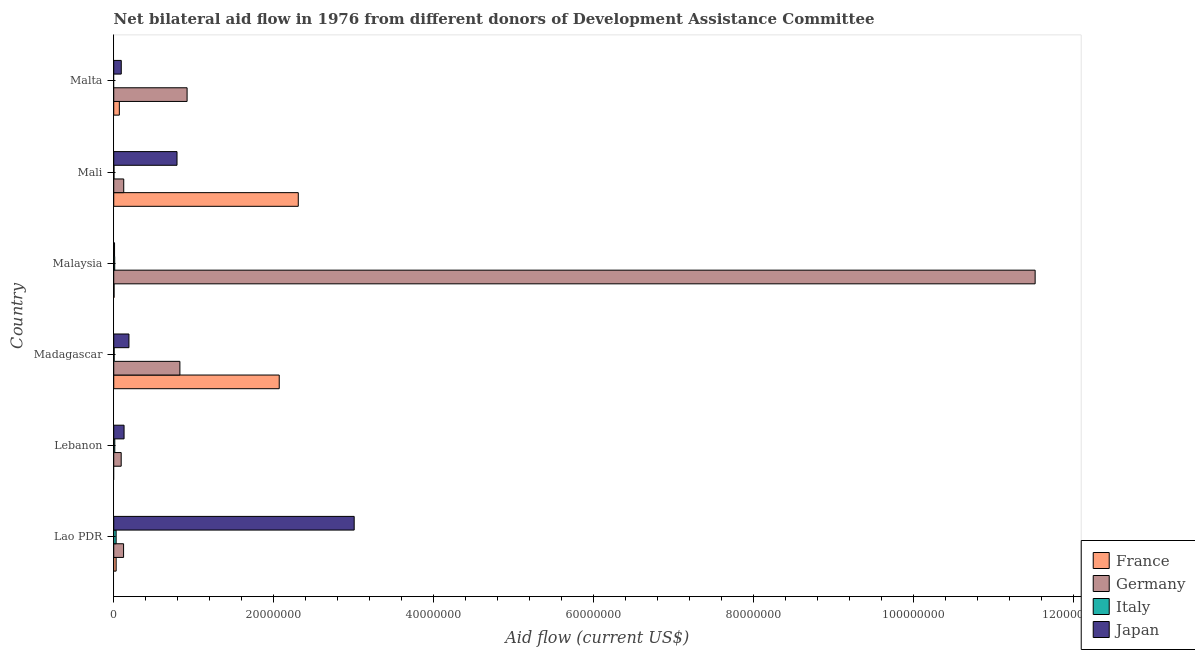How many groups of bars are there?
Your answer should be compact. 6. What is the label of the 4th group of bars from the top?
Provide a succinct answer. Madagascar. In how many cases, is the number of bars for a given country not equal to the number of legend labels?
Make the answer very short. 2. What is the amount of aid given by france in Lao PDR?
Make the answer very short. 3.00e+05. Across all countries, what is the maximum amount of aid given by italy?
Keep it short and to the point. 3.00e+05. In which country was the amount of aid given by japan maximum?
Make the answer very short. Lao PDR. What is the total amount of aid given by france in the graph?
Ensure brevity in your answer.  4.48e+07. What is the difference between the amount of aid given by germany in Lebanon and that in Mali?
Offer a terse response. -3.20e+05. What is the difference between the amount of aid given by italy in Malaysia and the amount of aid given by germany in Lao PDR?
Your answer should be very brief. -1.11e+06. What is the average amount of aid given by japan per country?
Offer a terse response. 7.03e+06. What is the difference between the amount of aid given by italy and amount of aid given by japan in Lebanon?
Ensure brevity in your answer.  -1.16e+06. In how many countries, is the amount of aid given by germany greater than 84000000 US$?
Ensure brevity in your answer.  1. Is the amount of aid given by france in Lao PDR less than that in Mali?
Keep it short and to the point. Yes. What is the difference between the highest and the second highest amount of aid given by france?
Ensure brevity in your answer.  2.38e+06. What is the difference between the highest and the lowest amount of aid given by italy?
Your response must be concise. 3.00e+05. Is the sum of the amount of aid given by japan in Lao PDR and Malaysia greater than the maximum amount of aid given by france across all countries?
Your response must be concise. Yes. Is it the case that in every country, the sum of the amount of aid given by france and amount of aid given by germany is greater than the amount of aid given by italy?
Ensure brevity in your answer.  Yes. What is the difference between two consecutive major ticks on the X-axis?
Provide a succinct answer. 2.00e+07. Does the graph contain any zero values?
Give a very brief answer. Yes. How many legend labels are there?
Offer a terse response. 4. What is the title of the graph?
Your response must be concise. Net bilateral aid flow in 1976 from different donors of Development Assistance Committee. What is the label or title of the Y-axis?
Your response must be concise. Country. What is the Aid flow (current US$) in Germany in Lao PDR?
Your answer should be compact. 1.23e+06. What is the Aid flow (current US$) of Italy in Lao PDR?
Your answer should be compact. 3.00e+05. What is the Aid flow (current US$) in Japan in Lao PDR?
Your response must be concise. 3.01e+07. What is the Aid flow (current US$) of Germany in Lebanon?
Your answer should be compact. 9.30e+05. What is the Aid flow (current US$) in Japan in Lebanon?
Your answer should be compact. 1.29e+06. What is the Aid flow (current US$) of France in Madagascar?
Your response must be concise. 2.07e+07. What is the Aid flow (current US$) of Germany in Madagascar?
Give a very brief answer. 8.27e+06. What is the Aid flow (current US$) in Japan in Madagascar?
Your answer should be very brief. 1.90e+06. What is the Aid flow (current US$) in France in Malaysia?
Ensure brevity in your answer.  4.00e+04. What is the Aid flow (current US$) of Germany in Malaysia?
Offer a very short reply. 1.15e+08. What is the Aid flow (current US$) of Italy in Malaysia?
Your answer should be compact. 1.20e+05. What is the Aid flow (current US$) of France in Mali?
Provide a succinct answer. 2.31e+07. What is the Aid flow (current US$) in Germany in Mali?
Give a very brief answer. 1.25e+06. What is the Aid flow (current US$) in Italy in Mali?
Ensure brevity in your answer.  3.00e+04. What is the Aid flow (current US$) of Japan in Mali?
Keep it short and to the point. 7.91e+06. What is the Aid flow (current US$) in France in Malta?
Give a very brief answer. 7.00e+05. What is the Aid flow (current US$) of Germany in Malta?
Your answer should be very brief. 9.17e+06. What is the Aid flow (current US$) of Japan in Malta?
Make the answer very short. 9.40e+05. Across all countries, what is the maximum Aid flow (current US$) of France?
Provide a short and direct response. 2.31e+07. Across all countries, what is the maximum Aid flow (current US$) of Germany?
Ensure brevity in your answer.  1.15e+08. Across all countries, what is the maximum Aid flow (current US$) in Italy?
Your answer should be very brief. 3.00e+05. Across all countries, what is the maximum Aid flow (current US$) of Japan?
Your answer should be compact. 3.01e+07. Across all countries, what is the minimum Aid flow (current US$) of Germany?
Give a very brief answer. 9.30e+05. Across all countries, what is the minimum Aid flow (current US$) in Italy?
Ensure brevity in your answer.  0. Across all countries, what is the minimum Aid flow (current US$) in Japan?
Your answer should be compact. 1.00e+05. What is the total Aid flow (current US$) of France in the graph?
Give a very brief answer. 4.48e+07. What is the total Aid flow (current US$) of Germany in the graph?
Offer a terse response. 1.36e+08. What is the total Aid flow (current US$) of Italy in the graph?
Ensure brevity in your answer.  6.30e+05. What is the total Aid flow (current US$) in Japan in the graph?
Your answer should be compact. 4.22e+07. What is the difference between the Aid flow (current US$) in Italy in Lao PDR and that in Lebanon?
Provide a succinct answer. 1.70e+05. What is the difference between the Aid flow (current US$) in Japan in Lao PDR and that in Lebanon?
Provide a short and direct response. 2.88e+07. What is the difference between the Aid flow (current US$) in France in Lao PDR and that in Madagascar?
Give a very brief answer. -2.04e+07. What is the difference between the Aid flow (current US$) of Germany in Lao PDR and that in Madagascar?
Provide a short and direct response. -7.04e+06. What is the difference between the Aid flow (current US$) of Japan in Lao PDR and that in Madagascar?
Provide a short and direct response. 2.82e+07. What is the difference between the Aid flow (current US$) of Germany in Lao PDR and that in Malaysia?
Ensure brevity in your answer.  -1.14e+08. What is the difference between the Aid flow (current US$) of Japan in Lao PDR and that in Malaysia?
Your response must be concise. 3.00e+07. What is the difference between the Aid flow (current US$) in France in Lao PDR and that in Mali?
Provide a short and direct response. -2.28e+07. What is the difference between the Aid flow (current US$) in Japan in Lao PDR and that in Mali?
Provide a short and direct response. 2.22e+07. What is the difference between the Aid flow (current US$) of France in Lao PDR and that in Malta?
Your answer should be very brief. -4.00e+05. What is the difference between the Aid flow (current US$) in Germany in Lao PDR and that in Malta?
Keep it short and to the point. -7.94e+06. What is the difference between the Aid flow (current US$) in Japan in Lao PDR and that in Malta?
Give a very brief answer. 2.91e+07. What is the difference between the Aid flow (current US$) of Germany in Lebanon and that in Madagascar?
Your answer should be compact. -7.34e+06. What is the difference between the Aid flow (current US$) of Italy in Lebanon and that in Madagascar?
Make the answer very short. 8.00e+04. What is the difference between the Aid flow (current US$) of Japan in Lebanon and that in Madagascar?
Provide a succinct answer. -6.10e+05. What is the difference between the Aid flow (current US$) in Germany in Lebanon and that in Malaysia?
Ensure brevity in your answer.  -1.14e+08. What is the difference between the Aid flow (current US$) of Japan in Lebanon and that in Malaysia?
Your answer should be very brief. 1.19e+06. What is the difference between the Aid flow (current US$) in Germany in Lebanon and that in Mali?
Offer a very short reply. -3.20e+05. What is the difference between the Aid flow (current US$) of Japan in Lebanon and that in Mali?
Provide a short and direct response. -6.62e+06. What is the difference between the Aid flow (current US$) of Germany in Lebanon and that in Malta?
Make the answer very short. -8.24e+06. What is the difference between the Aid flow (current US$) of France in Madagascar and that in Malaysia?
Your answer should be compact. 2.06e+07. What is the difference between the Aid flow (current US$) in Germany in Madagascar and that in Malaysia?
Offer a terse response. -1.07e+08. What is the difference between the Aid flow (current US$) in Japan in Madagascar and that in Malaysia?
Keep it short and to the point. 1.80e+06. What is the difference between the Aid flow (current US$) of France in Madagascar and that in Mali?
Your answer should be compact. -2.38e+06. What is the difference between the Aid flow (current US$) in Germany in Madagascar and that in Mali?
Your response must be concise. 7.02e+06. What is the difference between the Aid flow (current US$) of Italy in Madagascar and that in Mali?
Provide a succinct answer. 2.00e+04. What is the difference between the Aid flow (current US$) in Japan in Madagascar and that in Mali?
Provide a succinct answer. -6.01e+06. What is the difference between the Aid flow (current US$) of France in Madagascar and that in Malta?
Give a very brief answer. 2.00e+07. What is the difference between the Aid flow (current US$) in Germany in Madagascar and that in Malta?
Provide a short and direct response. -9.00e+05. What is the difference between the Aid flow (current US$) of Japan in Madagascar and that in Malta?
Give a very brief answer. 9.60e+05. What is the difference between the Aid flow (current US$) of France in Malaysia and that in Mali?
Offer a very short reply. -2.30e+07. What is the difference between the Aid flow (current US$) in Germany in Malaysia and that in Mali?
Your answer should be very brief. 1.14e+08. What is the difference between the Aid flow (current US$) of Italy in Malaysia and that in Mali?
Your answer should be compact. 9.00e+04. What is the difference between the Aid flow (current US$) of Japan in Malaysia and that in Mali?
Offer a very short reply. -7.81e+06. What is the difference between the Aid flow (current US$) in France in Malaysia and that in Malta?
Provide a short and direct response. -6.60e+05. What is the difference between the Aid flow (current US$) in Germany in Malaysia and that in Malta?
Your response must be concise. 1.06e+08. What is the difference between the Aid flow (current US$) of Japan in Malaysia and that in Malta?
Your response must be concise. -8.40e+05. What is the difference between the Aid flow (current US$) of France in Mali and that in Malta?
Your answer should be compact. 2.24e+07. What is the difference between the Aid flow (current US$) of Germany in Mali and that in Malta?
Offer a very short reply. -7.92e+06. What is the difference between the Aid flow (current US$) of Japan in Mali and that in Malta?
Provide a succinct answer. 6.97e+06. What is the difference between the Aid flow (current US$) in France in Lao PDR and the Aid flow (current US$) in Germany in Lebanon?
Offer a very short reply. -6.30e+05. What is the difference between the Aid flow (current US$) in France in Lao PDR and the Aid flow (current US$) in Japan in Lebanon?
Your answer should be compact. -9.90e+05. What is the difference between the Aid flow (current US$) in Germany in Lao PDR and the Aid flow (current US$) in Italy in Lebanon?
Your answer should be compact. 1.10e+06. What is the difference between the Aid flow (current US$) of Germany in Lao PDR and the Aid flow (current US$) of Japan in Lebanon?
Your answer should be very brief. -6.00e+04. What is the difference between the Aid flow (current US$) in Italy in Lao PDR and the Aid flow (current US$) in Japan in Lebanon?
Your answer should be very brief. -9.90e+05. What is the difference between the Aid flow (current US$) in France in Lao PDR and the Aid flow (current US$) in Germany in Madagascar?
Provide a short and direct response. -7.97e+06. What is the difference between the Aid flow (current US$) in France in Lao PDR and the Aid flow (current US$) in Japan in Madagascar?
Provide a short and direct response. -1.60e+06. What is the difference between the Aid flow (current US$) of Germany in Lao PDR and the Aid flow (current US$) of Italy in Madagascar?
Offer a terse response. 1.18e+06. What is the difference between the Aid flow (current US$) in Germany in Lao PDR and the Aid flow (current US$) in Japan in Madagascar?
Ensure brevity in your answer.  -6.70e+05. What is the difference between the Aid flow (current US$) in Italy in Lao PDR and the Aid flow (current US$) in Japan in Madagascar?
Make the answer very short. -1.60e+06. What is the difference between the Aid flow (current US$) in France in Lao PDR and the Aid flow (current US$) in Germany in Malaysia?
Offer a terse response. -1.15e+08. What is the difference between the Aid flow (current US$) in France in Lao PDR and the Aid flow (current US$) in Italy in Malaysia?
Provide a short and direct response. 1.80e+05. What is the difference between the Aid flow (current US$) of Germany in Lao PDR and the Aid flow (current US$) of Italy in Malaysia?
Offer a terse response. 1.11e+06. What is the difference between the Aid flow (current US$) in Germany in Lao PDR and the Aid flow (current US$) in Japan in Malaysia?
Your answer should be compact. 1.13e+06. What is the difference between the Aid flow (current US$) of France in Lao PDR and the Aid flow (current US$) of Germany in Mali?
Give a very brief answer. -9.50e+05. What is the difference between the Aid flow (current US$) of France in Lao PDR and the Aid flow (current US$) of Japan in Mali?
Your response must be concise. -7.61e+06. What is the difference between the Aid flow (current US$) in Germany in Lao PDR and the Aid flow (current US$) in Italy in Mali?
Offer a very short reply. 1.20e+06. What is the difference between the Aid flow (current US$) of Germany in Lao PDR and the Aid flow (current US$) of Japan in Mali?
Your answer should be compact. -6.68e+06. What is the difference between the Aid flow (current US$) in Italy in Lao PDR and the Aid flow (current US$) in Japan in Mali?
Your answer should be compact. -7.61e+06. What is the difference between the Aid flow (current US$) of France in Lao PDR and the Aid flow (current US$) of Germany in Malta?
Make the answer very short. -8.87e+06. What is the difference between the Aid flow (current US$) of France in Lao PDR and the Aid flow (current US$) of Japan in Malta?
Your response must be concise. -6.40e+05. What is the difference between the Aid flow (current US$) of Germany in Lao PDR and the Aid flow (current US$) of Japan in Malta?
Offer a very short reply. 2.90e+05. What is the difference between the Aid flow (current US$) of Italy in Lao PDR and the Aid flow (current US$) of Japan in Malta?
Offer a terse response. -6.40e+05. What is the difference between the Aid flow (current US$) of Germany in Lebanon and the Aid flow (current US$) of Italy in Madagascar?
Provide a short and direct response. 8.80e+05. What is the difference between the Aid flow (current US$) of Germany in Lebanon and the Aid flow (current US$) of Japan in Madagascar?
Your answer should be very brief. -9.70e+05. What is the difference between the Aid flow (current US$) of Italy in Lebanon and the Aid flow (current US$) of Japan in Madagascar?
Keep it short and to the point. -1.77e+06. What is the difference between the Aid flow (current US$) in Germany in Lebanon and the Aid flow (current US$) in Italy in Malaysia?
Provide a succinct answer. 8.10e+05. What is the difference between the Aid flow (current US$) of Germany in Lebanon and the Aid flow (current US$) of Japan in Malaysia?
Provide a succinct answer. 8.30e+05. What is the difference between the Aid flow (current US$) in Italy in Lebanon and the Aid flow (current US$) in Japan in Malaysia?
Your response must be concise. 3.00e+04. What is the difference between the Aid flow (current US$) of Germany in Lebanon and the Aid flow (current US$) of Italy in Mali?
Offer a terse response. 9.00e+05. What is the difference between the Aid flow (current US$) in Germany in Lebanon and the Aid flow (current US$) in Japan in Mali?
Keep it short and to the point. -6.98e+06. What is the difference between the Aid flow (current US$) in Italy in Lebanon and the Aid flow (current US$) in Japan in Mali?
Provide a succinct answer. -7.78e+06. What is the difference between the Aid flow (current US$) of Italy in Lebanon and the Aid flow (current US$) of Japan in Malta?
Offer a terse response. -8.10e+05. What is the difference between the Aid flow (current US$) in France in Madagascar and the Aid flow (current US$) in Germany in Malaysia?
Your response must be concise. -9.45e+07. What is the difference between the Aid flow (current US$) of France in Madagascar and the Aid flow (current US$) of Italy in Malaysia?
Your response must be concise. 2.06e+07. What is the difference between the Aid flow (current US$) of France in Madagascar and the Aid flow (current US$) of Japan in Malaysia?
Ensure brevity in your answer.  2.06e+07. What is the difference between the Aid flow (current US$) in Germany in Madagascar and the Aid flow (current US$) in Italy in Malaysia?
Ensure brevity in your answer.  8.15e+06. What is the difference between the Aid flow (current US$) in Germany in Madagascar and the Aid flow (current US$) in Japan in Malaysia?
Provide a succinct answer. 8.17e+06. What is the difference between the Aid flow (current US$) of Italy in Madagascar and the Aid flow (current US$) of Japan in Malaysia?
Your response must be concise. -5.00e+04. What is the difference between the Aid flow (current US$) of France in Madagascar and the Aid flow (current US$) of Germany in Mali?
Your response must be concise. 1.94e+07. What is the difference between the Aid flow (current US$) in France in Madagascar and the Aid flow (current US$) in Italy in Mali?
Offer a terse response. 2.07e+07. What is the difference between the Aid flow (current US$) in France in Madagascar and the Aid flow (current US$) in Japan in Mali?
Your response must be concise. 1.28e+07. What is the difference between the Aid flow (current US$) in Germany in Madagascar and the Aid flow (current US$) in Italy in Mali?
Make the answer very short. 8.24e+06. What is the difference between the Aid flow (current US$) of Germany in Madagascar and the Aid flow (current US$) of Japan in Mali?
Make the answer very short. 3.60e+05. What is the difference between the Aid flow (current US$) in Italy in Madagascar and the Aid flow (current US$) in Japan in Mali?
Offer a terse response. -7.86e+06. What is the difference between the Aid flow (current US$) of France in Madagascar and the Aid flow (current US$) of Germany in Malta?
Your response must be concise. 1.15e+07. What is the difference between the Aid flow (current US$) of France in Madagascar and the Aid flow (current US$) of Japan in Malta?
Your response must be concise. 1.98e+07. What is the difference between the Aid flow (current US$) in Germany in Madagascar and the Aid flow (current US$) in Japan in Malta?
Offer a very short reply. 7.33e+06. What is the difference between the Aid flow (current US$) of Italy in Madagascar and the Aid flow (current US$) of Japan in Malta?
Offer a very short reply. -8.90e+05. What is the difference between the Aid flow (current US$) of France in Malaysia and the Aid flow (current US$) of Germany in Mali?
Your answer should be very brief. -1.21e+06. What is the difference between the Aid flow (current US$) in France in Malaysia and the Aid flow (current US$) in Italy in Mali?
Your answer should be very brief. 10000. What is the difference between the Aid flow (current US$) in France in Malaysia and the Aid flow (current US$) in Japan in Mali?
Offer a terse response. -7.87e+06. What is the difference between the Aid flow (current US$) in Germany in Malaysia and the Aid flow (current US$) in Italy in Mali?
Offer a very short reply. 1.15e+08. What is the difference between the Aid flow (current US$) in Germany in Malaysia and the Aid flow (current US$) in Japan in Mali?
Offer a very short reply. 1.07e+08. What is the difference between the Aid flow (current US$) of Italy in Malaysia and the Aid flow (current US$) of Japan in Mali?
Provide a short and direct response. -7.79e+06. What is the difference between the Aid flow (current US$) of France in Malaysia and the Aid flow (current US$) of Germany in Malta?
Provide a succinct answer. -9.13e+06. What is the difference between the Aid flow (current US$) of France in Malaysia and the Aid flow (current US$) of Japan in Malta?
Offer a terse response. -9.00e+05. What is the difference between the Aid flow (current US$) in Germany in Malaysia and the Aid flow (current US$) in Japan in Malta?
Offer a very short reply. 1.14e+08. What is the difference between the Aid flow (current US$) of Italy in Malaysia and the Aid flow (current US$) of Japan in Malta?
Provide a succinct answer. -8.20e+05. What is the difference between the Aid flow (current US$) of France in Mali and the Aid flow (current US$) of Germany in Malta?
Provide a succinct answer. 1.39e+07. What is the difference between the Aid flow (current US$) in France in Mali and the Aid flow (current US$) in Japan in Malta?
Provide a short and direct response. 2.21e+07. What is the difference between the Aid flow (current US$) of Germany in Mali and the Aid flow (current US$) of Japan in Malta?
Offer a terse response. 3.10e+05. What is the difference between the Aid flow (current US$) in Italy in Mali and the Aid flow (current US$) in Japan in Malta?
Ensure brevity in your answer.  -9.10e+05. What is the average Aid flow (current US$) in France per country?
Make the answer very short. 7.47e+06. What is the average Aid flow (current US$) of Germany per country?
Offer a terse response. 2.27e+07. What is the average Aid flow (current US$) in Italy per country?
Ensure brevity in your answer.  1.05e+05. What is the average Aid flow (current US$) of Japan per country?
Provide a short and direct response. 7.03e+06. What is the difference between the Aid flow (current US$) in France and Aid flow (current US$) in Germany in Lao PDR?
Your answer should be compact. -9.30e+05. What is the difference between the Aid flow (current US$) in France and Aid flow (current US$) in Japan in Lao PDR?
Provide a succinct answer. -2.98e+07. What is the difference between the Aid flow (current US$) of Germany and Aid flow (current US$) of Italy in Lao PDR?
Your answer should be compact. 9.30e+05. What is the difference between the Aid flow (current US$) of Germany and Aid flow (current US$) of Japan in Lao PDR?
Keep it short and to the point. -2.88e+07. What is the difference between the Aid flow (current US$) of Italy and Aid flow (current US$) of Japan in Lao PDR?
Offer a very short reply. -2.98e+07. What is the difference between the Aid flow (current US$) of Germany and Aid flow (current US$) of Italy in Lebanon?
Offer a terse response. 8.00e+05. What is the difference between the Aid flow (current US$) in Germany and Aid flow (current US$) in Japan in Lebanon?
Offer a terse response. -3.60e+05. What is the difference between the Aid flow (current US$) of Italy and Aid flow (current US$) of Japan in Lebanon?
Give a very brief answer. -1.16e+06. What is the difference between the Aid flow (current US$) in France and Aid flow (current US$) in Germany in Madagascar?
Offer a terse response. 1.24e+07. What is the difference between the Aid flow (current US$) in France and Aid flow (current US$) in Italy in Madagascar?
Give a very brief answer. 2.06e+07. What is the difference between the Aid flow (current US$) in France and Aid flow (current US$) in Japan in Madagascar?
Provide a short and direct response. 1.88e+07. What is the difference between the Aid flow (current US$) of Germany and Aid flow (current US$) of Italy in Madagascar?
Ensure brevity in your answer.  8.22e+06. What is the difference between the Aid flow (current US$) in Germany and Aid flow (current US$) in Japan in Madagascar?
Provide a short and direct response. 6.37e+06. What is the difference between the Aid flow (current US$) of Italy and Aid flow (current US$) of Japan in Madagascar?
Offer a terse response. -1.85e+06. What is the difference between the Aid flow (current US$) in France and Aid flow (current US$) in Germany in Malaysia?
Provide a short and direct response. -1.15e+08. What is the difference between the Aid flow (current US$) of France and Aid flow (current US$) of Japan in Malaysia?
Ensure brevity in your answer.  -6.00e+04. What is the difference between the Aid flow (current US$) in Germany and Aid flow (current US$) in Italy in Malaysia?
Your response must be concise. 1.15e+08. What is the difference between the Aid flow (current US$) in Germany and Aid flow (current US$) in Japan in Malaysia?
Offer a very short reply. 1.15e+08. What is the difference between the Aid flow (current US$) of Italy and Aid flow (current US$) of Japan in Malaysia?
Ensure brevity in your answer.  2.00e+04. What is the difference between the Aid flow (current US$) in France and Aid flow (current US$) in Germany in Mali?
Keep it short and to the point. 2.18e+07. What is the difference between the Aid flow (current US$) in France and Aid flow (current US$) in Italy in Mali?
Ensure brevity in your answer.  2.30e+07. What is the difference between the Aid flow (current US$) in France and Aid flow (current US$) in Japan in Mali?
Keep it short and to the point. 1.52e+07. What is the difference between the Aid flow (current US$) in Germany and Aid flow (current US$) in Italy in Mali?
Offer a terse response. 1.22e+06. What is the difference between the Aid flow (current US$) of Germany and Aid flow (current US$) of Japan in Mali?
Give a very brief answer. -6.66e+06. What is the difference between the Aid flow (current US$) of Italy and Aid flow (current US$) of Japan in Mali?
Provide a succinct answer. -7.88e+06. What is the difference between the Aid flow (current US$) in France and Aid flow (current US$) in Germany in Malta?
Give a very brief answer. -8.47e+06. What is the difference between the Aid flow (current US$) in Germany and Aid flow (current US$) in Japan in Malta?
Ensure brevity in your answer.  8.23e+06. What is the ratio of the Aid flow (current US$) in Germany in Lao PDR to that in Lebanon?
Give a very brief answer. 1.32. What is the ratio of the Aid flow (current US$) in Italy in Lao PDR to that in Lebanon?
Offer a very short reply. 2.31. What is the ratio of the Aid flow (current US$) of Japan in Lao PDR to that in Lebanon?
Provide a short and direct response. 23.3. What is the ratio of the Aid flow (current US$) of France in Lao PDR to that in Madagascar?
Offer a very short reply. 0.01. What is the ratio of the Aid flow (current US$) of Germany in Lao PDR to that in Madagascar?
Offer a terse response. 0.15. What is the ratio of the Aid flow (current US$) of Japan in Lao PDR to that in Madagascar?
Offer a terse response. 15.82. What is the ratio of the Aid flow (current US$) in France in Lao PDR to that in Malaysia?
Keep it short and to the point. 7.5. What is the ratio of the Aid flow (current US$) in Germany in Lao PDR to that in Malaysia?
Ensure brevity in your answer.  0.01. What is the ratio of the Aid flow (current US$) in Japan in Lao PDR to that in Malaysia?
Provide a succinct answer. 300.6. What is the ratio of the Aid flow (current US$) in France in Lao PDR to that in Mali?
Offer a terse response. 0.01. What is the ratio of the Aid flow (current US$) of Germany in Lao PDR to that in Mali?
Your response must be concise. 0.98. What is the ratio of the Aid flow (current US$) of Italy in Lao PDR to that in Mali?
Your response must be concise. 10. What is the ratio of the Aid flow (current US$) in Japan in Lao PDR to that in Mali?
Offer a terse response. 3.8. What is the ratio of the Aid flow (current US$) in France in Lao PDR to that in Malta?
Provide a short and direct response. 0.43. What is the ratio of the Aid flow (current US$) of Germany in Lao PDR to that in Malta?
Offer a very short reply. 0.13. What is the ratio of the Aid flow (current US$) of Japan in Lao PDR to that in Malta?
Your answer should be very brief. 31.98. What is the ratio of the Aid flow (current US$) in Germany in Lebanon to that in Madagascar?
Keep it short and to the point. 0.11. What is the ratio of the Aid flow (current US$) of Japan in Lebanon to that in Madagascar?
Keep it short and to the point. 0.68. What is the ratio of the Aid flow (current US$) in Germany in Lebanon to that in Malaysia?
Your answer should be compact. 0.01. What is the ratio of the Aid flow (current US$) of Italy in Lebanon to that in Malaysia?
Your answer should be compact. 1.08. What is the ratio of the Aid flow (current US$) of Germany in Lebanon to that in Mali?
Provide a short and direct response. 0.74. What is the ratio of the Aid flow (current US$) in Italy in Lebanon to that in Mali?
Ensure brevity in your answer.  4.33. What is the ratio of the Aid flow (current US$) of Japan in Lebanon to that in Mali?
Provide a succinct answer. 0.16. What is the ratio of the Aid flow (current US$) of Germany in Lebanon to that in Malta?
Ensure brevity in your answer.  0.1. What is the ratio of the Aid flow (current US$) in Japan in Lebanon to that in Malta?
Give a very brief answer. 1.37. What is the ratio of the Aid flow (current US$) in France in Madagascar to that in Malaysia?
Your answer should be compact. 517.25. What is the ratio of the Aid flow (current US$) in Germany in Madagascar to that in Malaysia?
Give a very brief answer. 0.07. What is the ratio of the Aid flow (current US$) of Italy in Madagascar to that in Malaysia?
Ensure brevity in your answer.  0.42. What is the ratio of the Aid flow (current US$) in France in Madagascar to that in Mali?
Give a very brief answer. 0.9. What is the ratio of the Aid flow (current US$) in Germany in Madagascar to that in Mali?
Your answer should be very brief. 6.62. What is the ratio of the Aid flow (current US$) of Japan in Madagascar to that in Mali?
Your answer should be very brief. 0.24. What is the ratio of the Aid flow (current US$) in France in Madagascar to that in Malta?
Offer a very short reply. 29.56. What is the ratio of the Aid flow (current US$) in Germany in Madagascar to that in Malta?
Make the answer very short. 0.9. What is the ratio of the Aid flow (current US$) in Japan in Madagascar to that in Malta?
Offer a very short reply. 2.02. What is the ratio of the Aid flow (current US$) in France in Malaysia to that in Mali?
Ensure brevity in your answer.  0. What is the ratio of the Aid flow (current US$) in Germany in Malaysia to that in Mali?
Your answer should be compact. 92.15. What is the ratio of the Aid flow (current US$) of Japan in Malaysia to that in Mali?
Your answer should be compact. 0.01. What is the ratio of the Aid flow (current US$) of France in Malaysia to that in Malta?
Provide a short and direct response. 0.06. What is the ratio of the Aid flow (current US$) of Germany in Malaysia to that in Malta?
Give a very brief answer. 12.56. What is the ratio of the Aid flow (current US$) of Japan in Malaysia to that in Malta?
Keep it short and to the point. 0.11. What is the ratio of the Aid flow (current US$) in France in Mali to that in Malta?
Ensure brevity in your answer.  32.96. What is the ratio of the Aid flow (current US$) in Germany in Mali to that in Malta?
Your answer should be compact. 0.14. What is the ratio of the Aid flow (current US$) of Japan in Mali to that in Malta?
Your answer should be very brief. 8.41. What is the difference between the highest and the second highest Aid flow (current US$) of France?
Keep it short and to the point. 2.38e+06. What is the difference between the highest and the second highest Aid flow (current US$) in Germany?
Make the answer very short. 1.06e+08. What is the difference between the highest and the second highest Aid flow (current US$) in Italy?
Your response must be concise. 1.70e+05. What is the difference between the highest and the second highest Aid flow (current US$) of Japan?
Your answer should be very brief. 2.22e+07. What is the difference between the highest and the lowest Aid flow (current US$) in France?
Your response must be concise. 2.31e+07. What is the difference between the highest and the lowest Aid flow (current US$) of Germany?
Provide a succinct answer. 1.14e+08. What is the difference between the highest and the lowest Aid flow (current US$) in Italy?
Make the answer very short. 3.00e+05. What is the difference between the highest and the lowest Aid flow (current US$) in Japan?
Make the answer very short. 3.00e+07. 